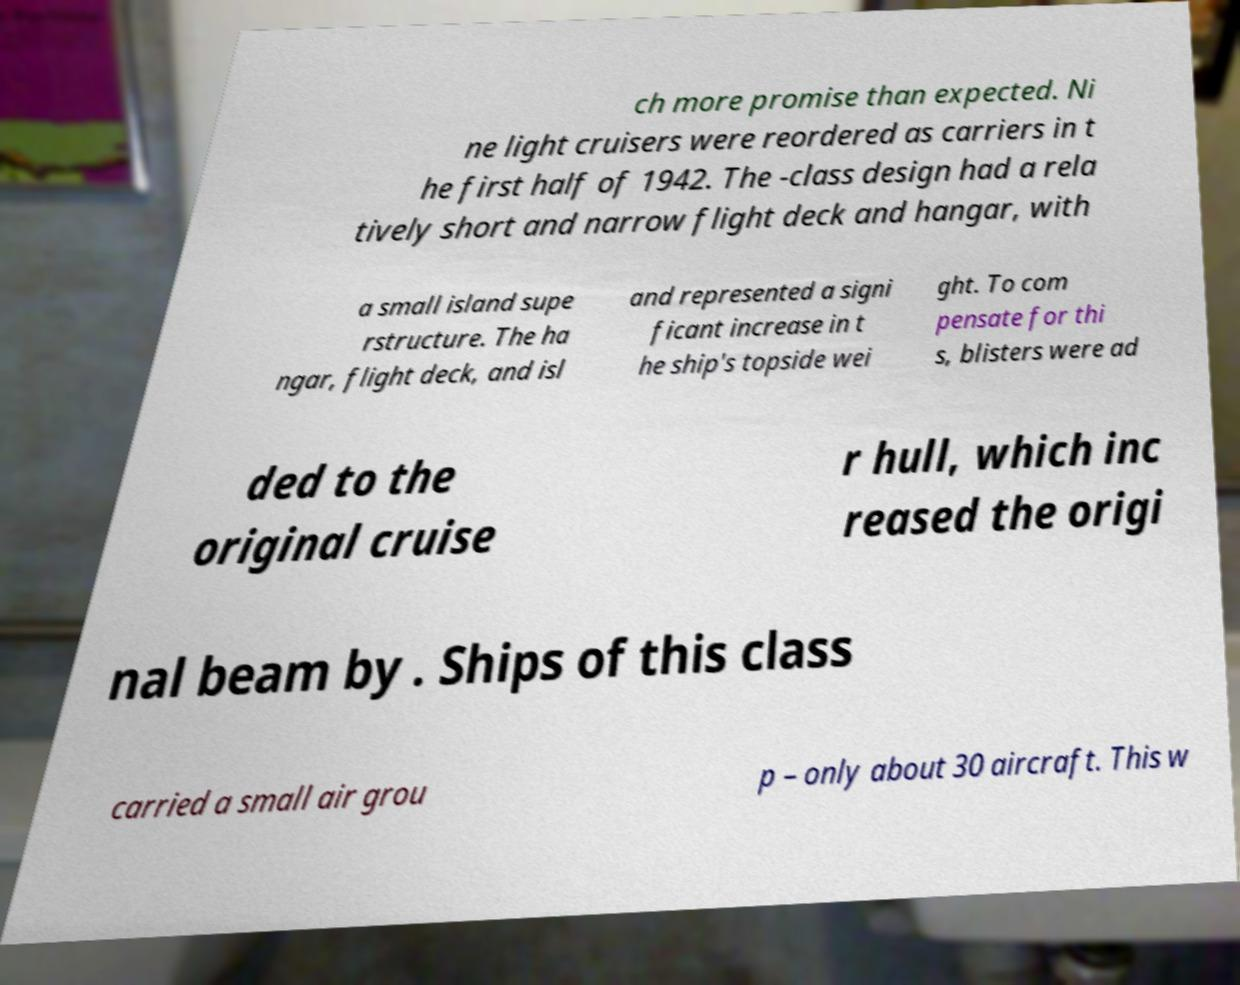I need the written content from this picture converted into text. Can you do that? ch more promise than expected. Ni ne light cruisers were reordered as carriers in t he first half of 1942. The -class design had a rela tively short and narrow flight deck and hangar, with a small island supe rstructure. The ha ngar, flight deck, and isl and represented a signi ficant increase in t he ship's topside wei ght. To com pensate for thi s, blisters were ad ded to the original cruise r hull, which inc reased the origi nal beam by . Ships of this class carried a small air grou p – only about 30 aircraft. This w 